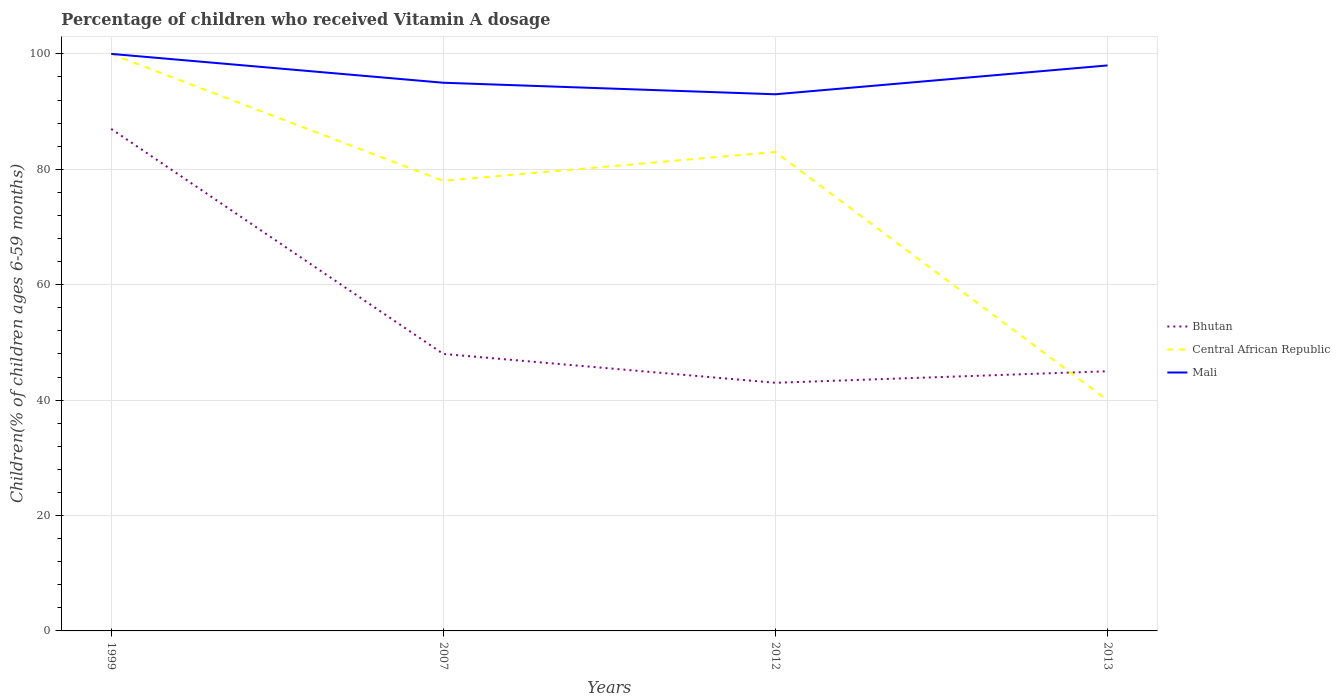How many different coloured lines are there?
Provide a short and direct response. 3. Across all years, what is the maximum percentage of children who received Vitamin A dosage in Bhutan?
Offer a very short reply. 43. What is the total percentage of children who received Vitamin A dosage in Mali in the graph?
Your answer should be compact. 2. What is the difference between the highest and the second highest percentage of children who received Vitamin A dosage in Mali?
Provide a succinct answer. 7. What is the difference between the highest and the lowest percentage of children who received Vitamin A dosage in Mali?
Offer a very short reply. 2. How many years are there in the graph?
Offer a terse response. 4. What is the difference between two consecutive major ticks on the Y-axis?
Ensure brevity in your answer.  20. Are the values on the major ticks of Y-axis written in scientific E-notation?
Make the answer very short. No. How many legend labels are there?
Provide a succinct answer. 3. What is the title of the graph?
Your answer should be very brief. Percentage of children who received Vitamin A dosage. Does "North America" appear as one of the legend labels in the graph?
Your answer should be compact. No. What is the label or title of the Y-axis?
Provide a succinct answer. Children(% of children ages 6-59 months). What is the Children(% of children ages 6-59 months) of Central African Republic in 1999?
Provide a succinct answer. 100. What is the Children(% of children ages 6-59 months) of Bhutan in 2007?
Ensure brevity in your answer.  48. What is the Children(% of children ages 6-59 months) of Central African Republic in 2007?
Provide a short and direct response. 78. What is the Children(% of children ages 6-59 months) of Mali in 2012?
Give a very brief answer. 93. What is the Children(% of children ages 6-59 months) in Central African Republic in 2013?
Your response must be concise. 40. Across all years, what is the maximum Children(% of children ages 6-59 months) in Bhutan?
Your answer should be very brief. 87. Across all years, what is the minimum Children(% of children ages 6-59 months) of Mali?
Give a very brief answer. 93. What is the total Children(% of children ages 6-59 months) in Bhutan in the graph?
Give a very brief answer. 223. What is the total Children(% of children ages 6-59 months) in Central African Republic in the graph?
Give a very brief answer. 301. What is the total Children(% of children ages 6-59 months) of Mali in the graph?
Give a very brief answer. 386. What is the difference between the Children(% of children ages 6-59 months) in Bhutan in 1999 and that in 2012?
Make the answer very short. 44. What is the difference between the Children(% of children ages 6-59 months) of Central African Republic in 1999 and that in 2012?
Offer a very short reply. 17. What is the difference between the Children(% of children ages 6-59 months) in Central African Republic in 1999 and that in 2013?
Provide a short and direct response. 60. What is the difference between the Children(% of children ages 6-59 months) of Central African Republic in 2007 and that in 2012?
Your answer should be very brief. -5. What is the difference between the Children(% of children ages 6-59 months) of Mali in 2007 and that in 2013?
Give a very brief answer. -3. What is the difference between the Children(% of children ages 6-59 months) of Central African Republic in 2012 and that in 2013?
Your answer should be very brief. 43. What is the difference between the Children(% of children ages 6-59 months) of Bhutan in 1999 and the Children(% of children ages 6-59 months) of Central African Republic in 2007?
Your answer should be compact. 9. What is the difference between the Children(% of children ages 6-59 months) of Bhutan in 1999 and the Children(% of children ages 6-59 months) of Central African Republic in 2012?
Keep it short and to the point. 4. What is the difference between the Children(% of children ages 6-59 months) in Central African Republic in 1999 and the Children(% of children ages 6-59 months) in Mali in 2012?
Make the answer very short. 7. What is the difference between the Children(% of children ages 6-59 months) of Bhutan in 1999 and the Children(% of children ages 6-59 months) of Central African Republic in 2013?
Your response must be concise. 47. What is the difference between the Children(% of children ages 6-59 months) of Central African Republic in 1999 and the Children(% of children ages 6-59 months) of Mali in 2013?
Your answer should be compact. 2. What is the difference between the Children(% of children ages 6-59 months) in Bhutan in 2007 and the Children(% of children ages 6-59 months) in Central African Republic in 2012?
Ensure brevity in your answer.  -35. What is the difference between the Children(% of children ages 6-59 months) of Bhutan in 2007 and the Children(% of children ages 6-59 months) of Mali in 2012?
Provide a succinct answer. -45. What is the difference between the Children(% of children ages 6-59 months) in Bhutan in 2007 and the Children(% of children ages 6-59 months) in Central African Republic in 2013?
Give a very brief answer. 8. What is the difference between the Children(% of children ages 6-59 months) of Bhutan in 2012 and the Children(% of children ages 6-59 months) of Central African Republic in 2013?
Offer a very short reply. 3. What is the difference between the Children(% of children ages 6-59 months) in Bhutan in 2012 and the Children(% of children ages 6-59 months) in Mali in 2013?
Give a very brief answer. -55. What is the difference between the Children(% of children ages 6-59 months) in Central African Republic in 2012 and the Children(% of children ages 6-59 months) in Mali in 2013?
Your answer should be compact. -15. What is the average Children(% of children ages 6-59 months) in Bhutan per year?
Provide a succinct answer. 55.75. What is the average Children(% of children ages 6-59 months) in Central African Republic per year?
Keep it short and to the point. 75.25. What is the average Children(% of children ages 6-59 months) of Mali per year?
Keep it short and to the point. 96.5. In the year 1999, what is the difference between the Children(% of children ages 6-59 months) in Bhutan and Children(% of children ages 6-59 months) in Mali?
Your answer should be very brief. -13. In the year 1999, what is the difference between the Children(% of children ages 6-59 months) of Central African Republic and Children(% of children ages 6-59 months) of Mali?
Keep it short and to the point. 0. In the year 2007, what is the difference between the Children(% of children ages 6-59 months) in Bhutan and Children(% of children ages 6-59 months) in Central African Republic?
Keep it short and to the point. -30. In the year 2007, what is the difference between the Children(% of children ages 6-59 months) of Bhutan and Children(% of children ages 6-59 months) of Mali?
Keep it short and to the point. -47. In the year 2012, what is the difference between the Children(% of children ages 6-59 months) of Bhutan and Children(% of children ages 6-59 months) of Mali?
Provide a short and direct response. -50. In the year 2013, what is the difference between the Children(% of children ages 6-59 months) of Bhutan and Children(% of children ages 6-59 months) of Central African Republic?
Provide a succinct answer. 5. In the year 2013, what is the difference between the Children(% of children ages 6-59 months) of Bhutan and Children(% of children ages 6-59 months) of Mali?
Ensure brevity in your answer.  -53. In the year 2013, what is the difference between the Children(% of children ages 6-59 months) in Central African Republic and Children(% of children ages 6-59 months) in Mali?
Your answer should be very brief. -58. What is the ratio of the Children(% of children ages 6-59 months) in Bhutan in 1999 to that in 2007?
Provide a short and direct response. 1.81. What is the ratio of the Children(% of children ages 6-59 months) in Central African Republic in 1999 to that in 2007?
Your answer should be compact. 1.28. What is the ratio of the Children(% of children ages 6-59 months) in Mali in 1999 to that in 2007?
Your answer should be compact. 1.05. What is the ratio of the Children(% of children ages 6-59 months) of Bhutan in 1999 to that in 2012?
Your answer should be compact. 2.02. What is the ratio of the Children(% of children ages 6-59 months) of Central African Republic in 1999 to that in 2012?
Provide a succinct answer. 1.2. What is the ratio of the Children(% of children ages 6-59 months) of Mali in 1999 to that in 2012?
Keep it short and to the point. 1.08. What is the ratio of the Children(% of children ages 6-59 months) in Bhutan in 1999 to that in 2013?
Offer a terse response. 1.93. What is the ratio of the Children(% of children ages 6-59 months) of Mali in 1999 to that in 2013?
Offer a terse response. 1.02. What is the ratio of the Children(% of children ages 6-59 months) in Bhutan in 2007 to that in 2012?
Offer a terse response. 1.12. What is the ratio of the Children(% of children ages 6-59 months) in Central African Republic in 2007 to that in 2012?
Provide a succinct answer. 0.94. What is the ratio of the Children(% of children ages 6-59 months) of Mali in 2007 to that in 2012?
Give a very brief answer. 1.02. What is the ratio of the Children(% of children ages 6-59 months) of Bhutan in 2007 to that in 2013?
Offer a terse response. 1.07. What is the ratio of the Children(% of children ages 6-59 months) in Central African Republic in 2007 to that in 2013?
Keep it short and to the point. 1.95. What is the ratio of the Children(% of children ages 6-59 months) in Mali in 2007 to that in 2013?
Keep it short and to the point. 0.97. What is the ratio of the Children(% of children ages 6-59 months) of Bhutan in 2012 to that in 2013?
Your answer should be very brief. 0.96. What is the ratio of the Children(% of children ages 6-59 months) of Central African Republic in 2012 to that in 2013?
Your response must be concise. 2.08. What is the ratio of the Children(% of children ages 6-59 months) of Mali in 2012 to that in 2013?
Your response must be concise. 0.95. What is the difference between the highest and the second highest Children(% of children ages 6-59 months) of Central African Republic?
Ensure brevity in your answer.  17. What is the difference between the highest and the lowest Children(% of children ages 6-59 months) in Bhutan?
Ensure brevity in your answer.  44. 